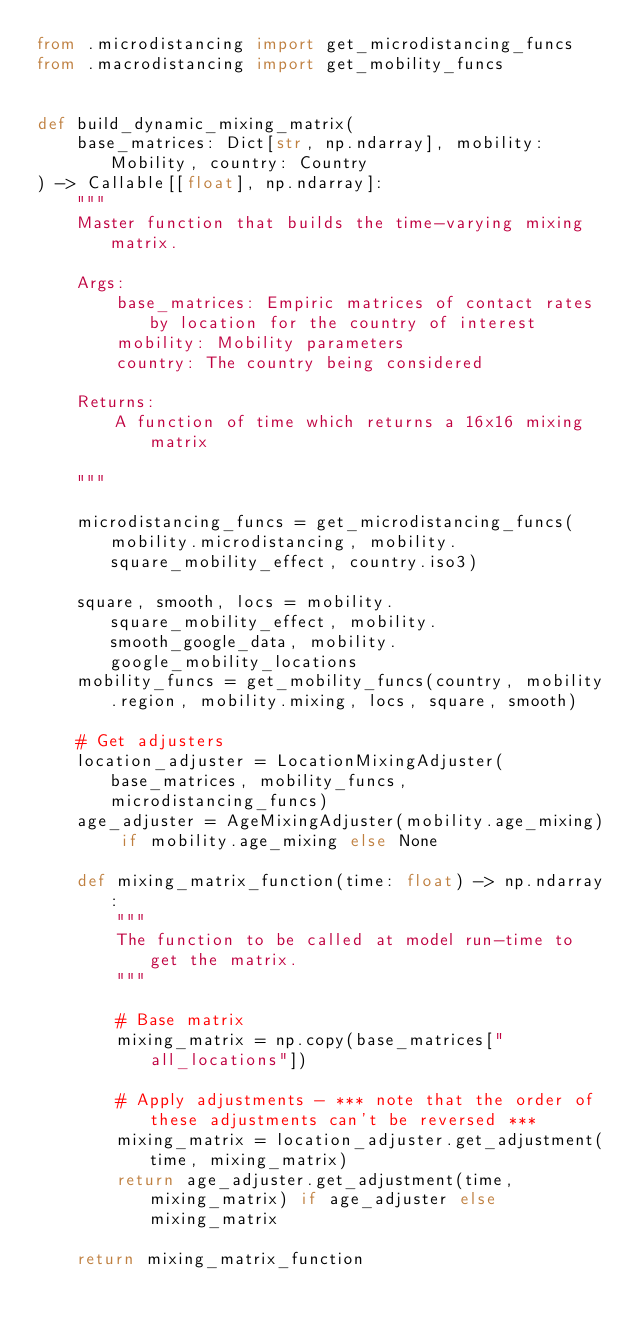Convert code to text. <code><loc_0><loc_0><loc_500><loc_500><_Python_>from .microdistancing import get_microdistancing_funcs
from .macrodistancing import get_mobility_funcs


def build_dynamic_mixing_matrix(
    base_matrices: Dict[str, np.ndarray], mobility: Mobility, country: Country
) -> Callable[[float], np.ndarray]:
    """
    Master function that builds the time-varying mixing matrix.

    Args:
        base_matrices: Empiric matrices of contact rates by location for the country of interest
        mobility: Mobility parameters
        country: The country being considered

    Returns:
        A function of time which returns a 16x16 mixing matrix

    """

    microdistancing_funcs = get_microdistancing_funcs(mobility.microdistancing, mobility.square_mobility_effect, country.iso3)

    square, smooth, locs = mobility.square_mobility_effect, mobility.smooth_google_data, mobility.google_mobility_locations
    mobility_funcs = get_mobility_funcs(country, mobility.region, mobility.mixing, locs, square, smooth)

    # Get adjusters
    location_adjuster = LocationMixingAdjuster(base_matrices, mobility_funcs, microdistancing_funcs)
    age_adjuster = AgeMixingAdjuster(mobility.age_mixing) if mobility.age_mixing else None

    def mixing_matrix_function(time: float) -> np.ndarray:
        """
        The function to be called at model run-time to get the matrix.
        """

        # Base matrix
        mixing_matrix = np.copy(base_matrices["all_locations"])

        # Apply adjustments - *** note that the order of these adjustments can't be reversed ***
        mixing_matrix = location_adjuster.get_adjustment(time, mixing_matrix)
        return age_adjuster.get_adjustment(time, mixing_matrix) if age_adjuster else mixing_matrix

    return mixing_matrix_function
</code> 